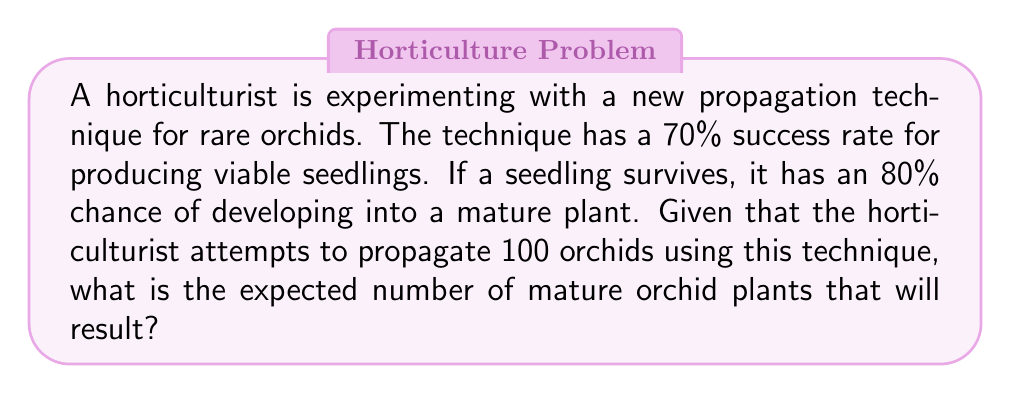Give your solution to this math problem. To solve this problem, we'll use the concept of compound probability and expected value. Let's break it down step-by-step:

1. Define the probabilities:
   - Probability of producing a viable seedling: $P(S) = 0.70$
   - Probability of a seedling developing into a mature plant: $P(M|S) = 0.80$

2. Calculate the probability of a single attempt resulting in a mature plant:
   $P(M) = P(S) \times P(M|S) = 0.70 \times 0.80 = 0.56$

3. Calculate the expected number of mature plants:
   - Number of attempts: $n = 100$
   - Probability of success for each attempt: $p = 0.56$
   - Expected value: $E(X) = n \times p$

   $$E(X) = 100 \times 0.56 = 56$$

Therefore, the expected number of mature orchid plants resulting from 100 propagation attempts is 56.
Answer: 56 mature orchid plants 